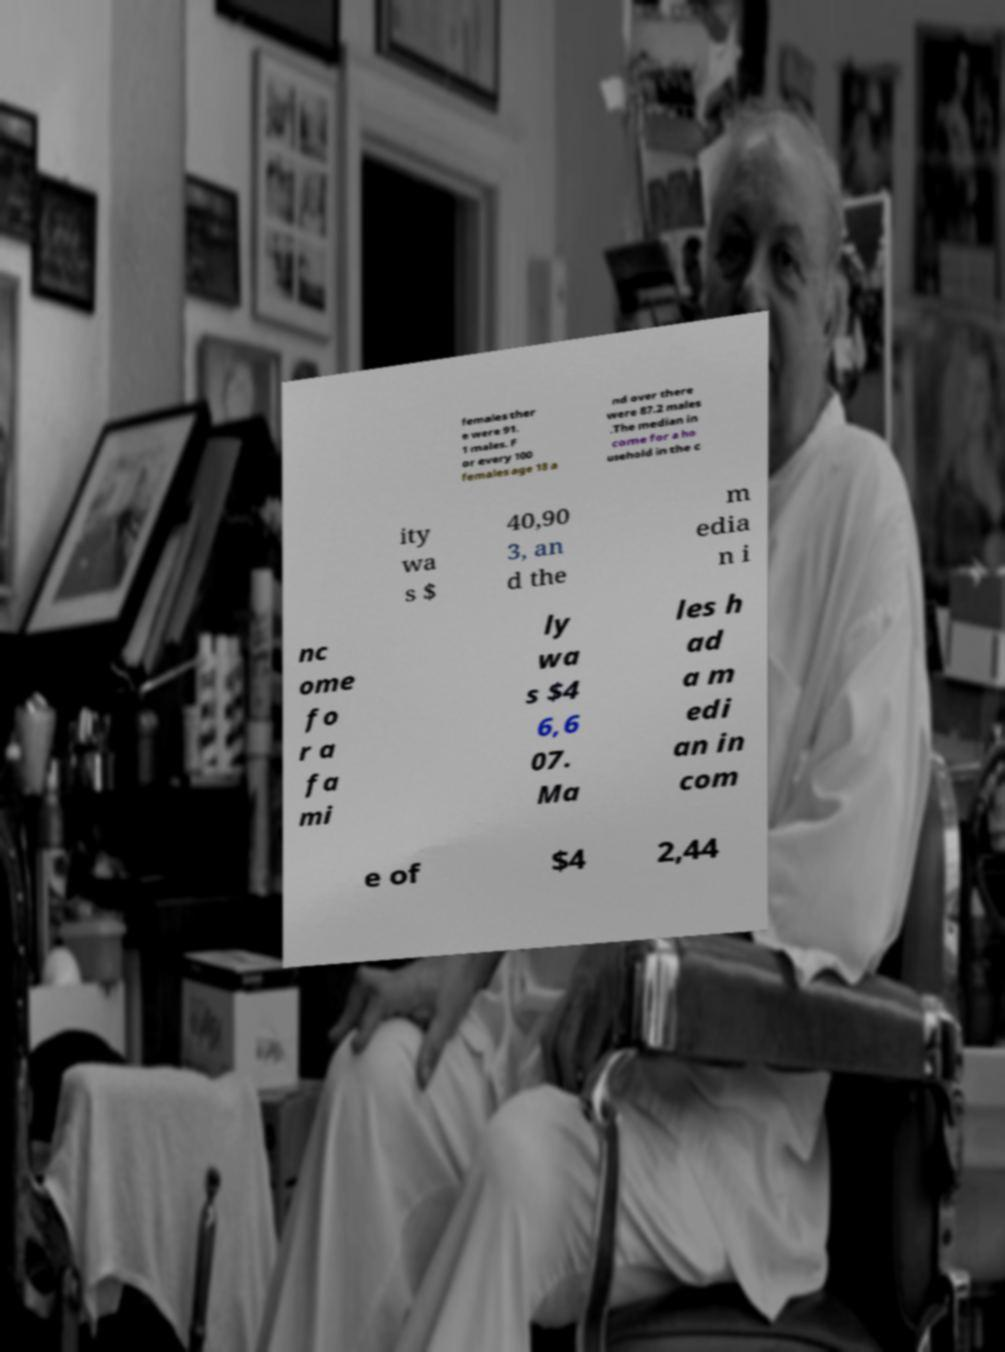I need the written content from this picture converted into text. Can you do that? females ther e were 91. 1 males. F or every 100 females age 18 a nd over there were 87.2 males .The median in come for a ho usehold in the c ity wa s $ 40,90 3, an d the m edia n i nc ome fo r a fa mi ly wa s $4 6,6 07. Ma les h ad a m edi an in com e of $4 2,44 